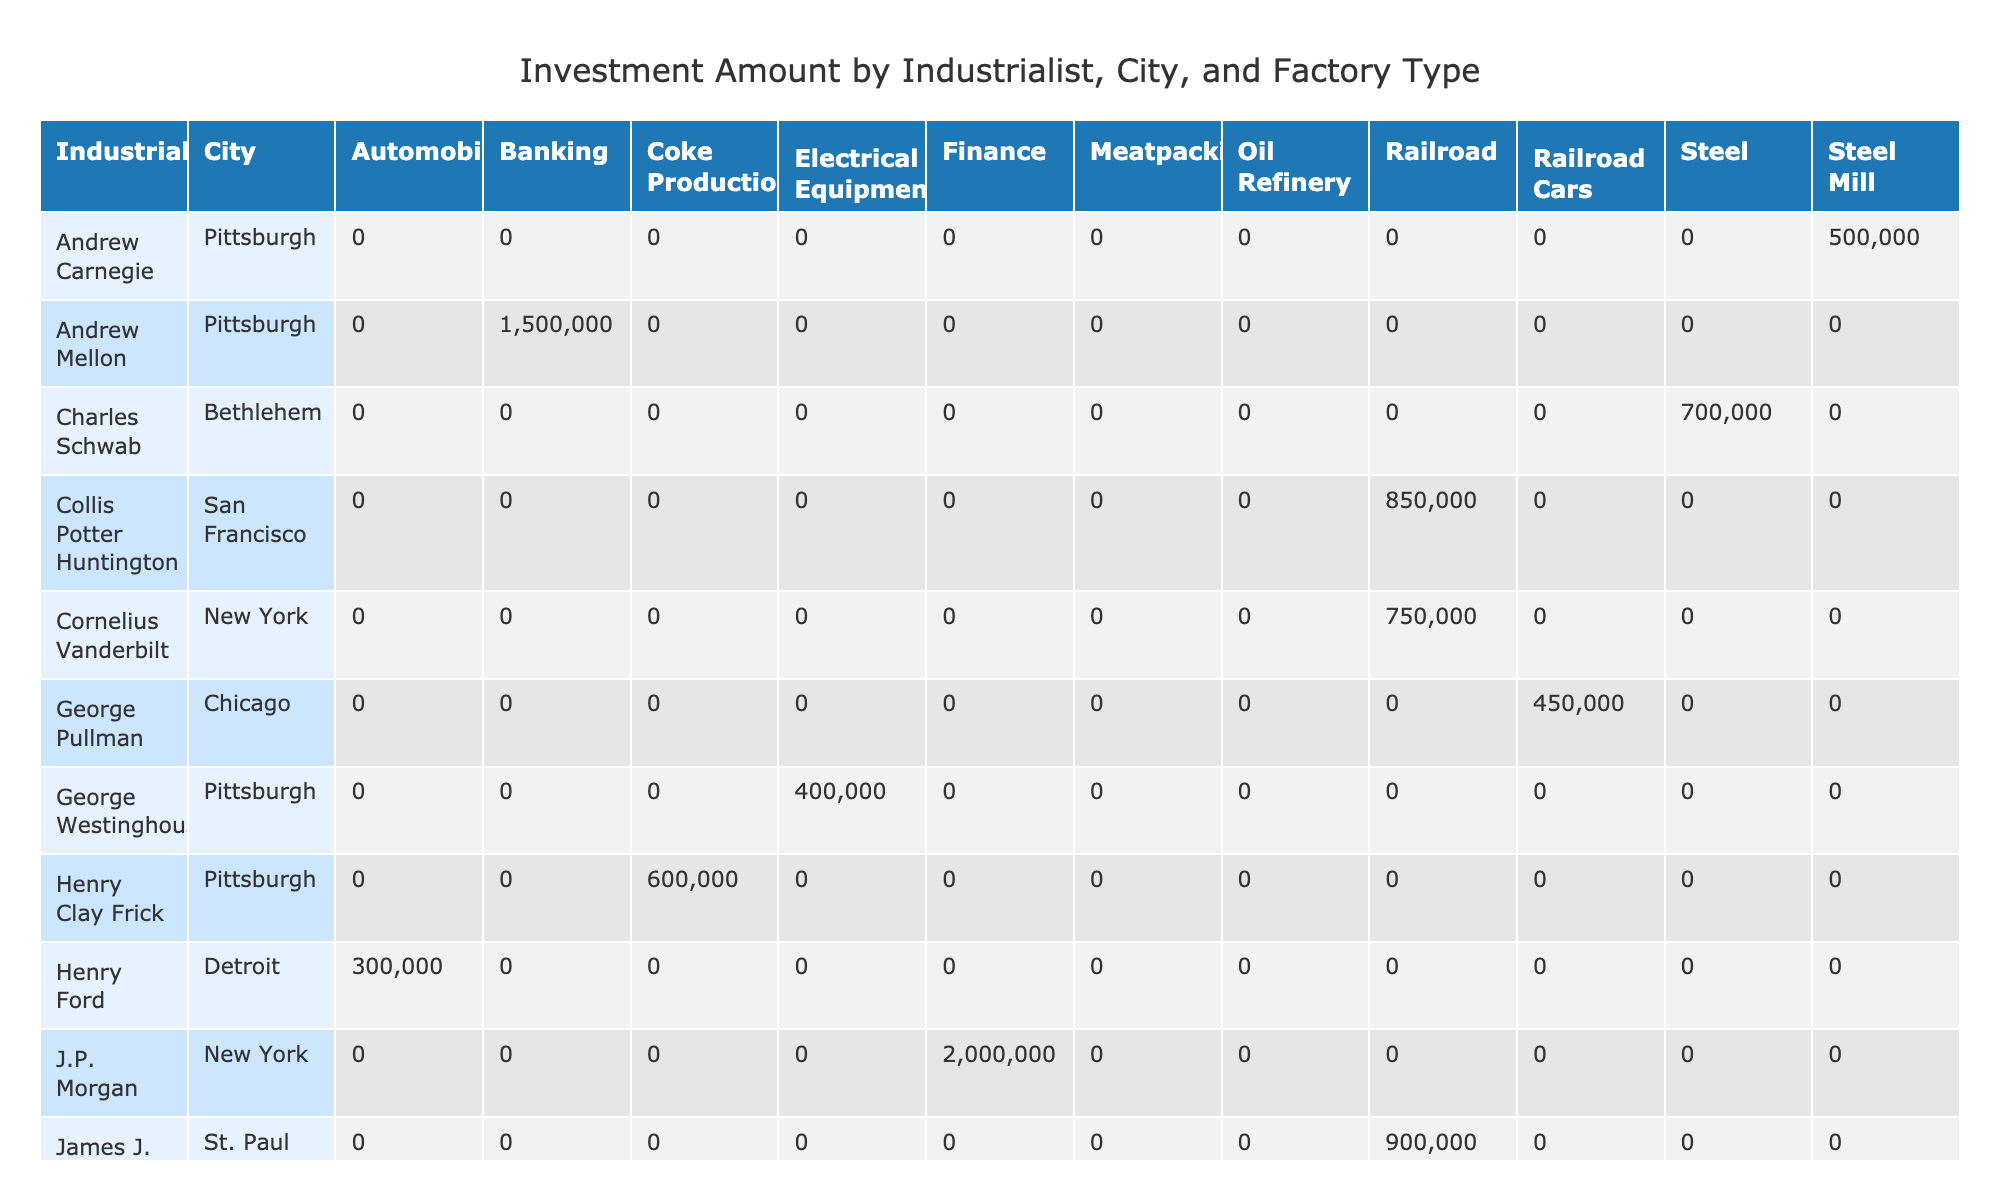What is the total investment amount from industrialists in Pittsburgh? The table lists four industrialists associated with Pittsburgh: Andrew Carnegie, Henry Clay Frick, George Westinghouse, and Andrew Mellon. The investment amounts for these individuals are 500,000, 600,000, 400,000, and 1,500,000 respectively. Adding these values together gives a total investment of 500,000 + 600,000 + 400,000 + 1,500,000 = 3,000,000.
Answer: 3,000,000 Which industrialist donated the most amount to charity? From the table, the charitable donations are listed for each industrialist. The highest amount is from J.P. Morgan, who donated 200,000. This is compared to other donations: Andrew Carnegie 50,000, Cornelius Vanderbilt 75,000, and so on, showing that J.P. Morgan's donation is the highest.
Answer: J.P. Morgan Is there an industrialist who created more than 1800 jobs? By reviewing the 'Jobs Created' column, we see that only J.P. Morgan (2000 jobs) and Andrew Mellon (1800 jobs) created 1800 or more jobs, making it true that there are such industrialists.
Answer: Yes What is the average investment amount per job created for John D. Rockefeller? John D. Rockefeller invested 1,000,000 and created 1500 jobs. To find the average, we divide the investment amount by the jobs created: 1,000,000 / 1500 = 666.67.
Answer: 666.67 Are there more jobs created in the railroad industry compared to the steel industry? Analyzing the 'Jobs Created' for the railroad industry: Cornelius Vanderbilt (800), Leland Stanford (1000), James J. Hill (1300), Jay Gould (900), and Collis Potter Huntington (1200), gives a total of 800 + 1000 + 1300 + 900 + 1200 = 4200 jobs. For steel, only Andrew Carnegie (1200) and Charles Schwab (1100) created jobs, summing to 1200 + 1100 = 2300. Since 4200 > 2300, there are indeed more jobs created in the railroad industry.
Answer: Yes What is the total annual revenue generated by industrialists in New York? The industrialists in New York are Cornelius Vanderbilt (3,500,000) and J.P. Morgan (10,000,000). Adding these revenues together: 3,500,000 + 10,000,000 = 13,500,000.
Answer: 13,500,000 Do all industrialists from Pittsburgh have an investment amount greater than $500,000? Checking the investment amounts for Pittsburgh industrialists reveals: Andrew Carnegie 500,000, Henry Clay Frick 600,000, George Westinghouse 400,000, and Andrew Mellon 1,500,000. Since George Westinghouse's investment is 400,000 (less than 500,000), the statement is false.
Answer: No Which factory type contributed the most to job creation? By analyzing each factory type: Steel Mill (1200), Railroad (800 + 1000 + 1300 + 900 + 1200 = 4200), Oil Refinery (1500), Coke Production (1000), Banking (1800), and so on. The railroad industry leads with 4200 jobs.
Answer: Railroad What is the difference in charitable donations between J.P. Morgan and John D. Rockefeller? J.P. Morgan donated 200,000 while John D. Rockefeller donated 100,000. The difference is calculated as 200,000 - 100,000 = 100,000.
Answer: 100,000 